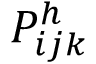Convert formula to latex. <formula><loc_0><loc_0><loc_500><loc_500>P _ { i j k } ^ { h }</formula> 